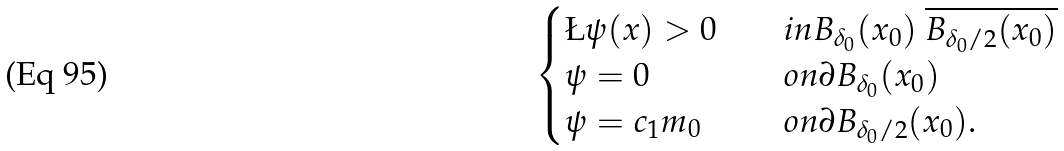Convert formula to latex. <formula><loc_0><loc_0><loc_500><loc_500>\begin{cases} \L \psi ( x ) > 0 & \quad i n B _ { \delta _ { 0 } } ( x _ { 0 } ) \ \overline { B _ { \delta _ { 0 } / 2 } ( x _ { 0 } ) } \\ \psi = 0 & \quad o n \partial B _ { \delta _ { 0 } } ( x _ { 0 } ) \\ \psi = c _ { 1 } m _ { 0 } & \quad o n \partial B _ { \delta _ { 0 } / 2 } ( x _ { 0 } ) . \end{cases}</formula> 